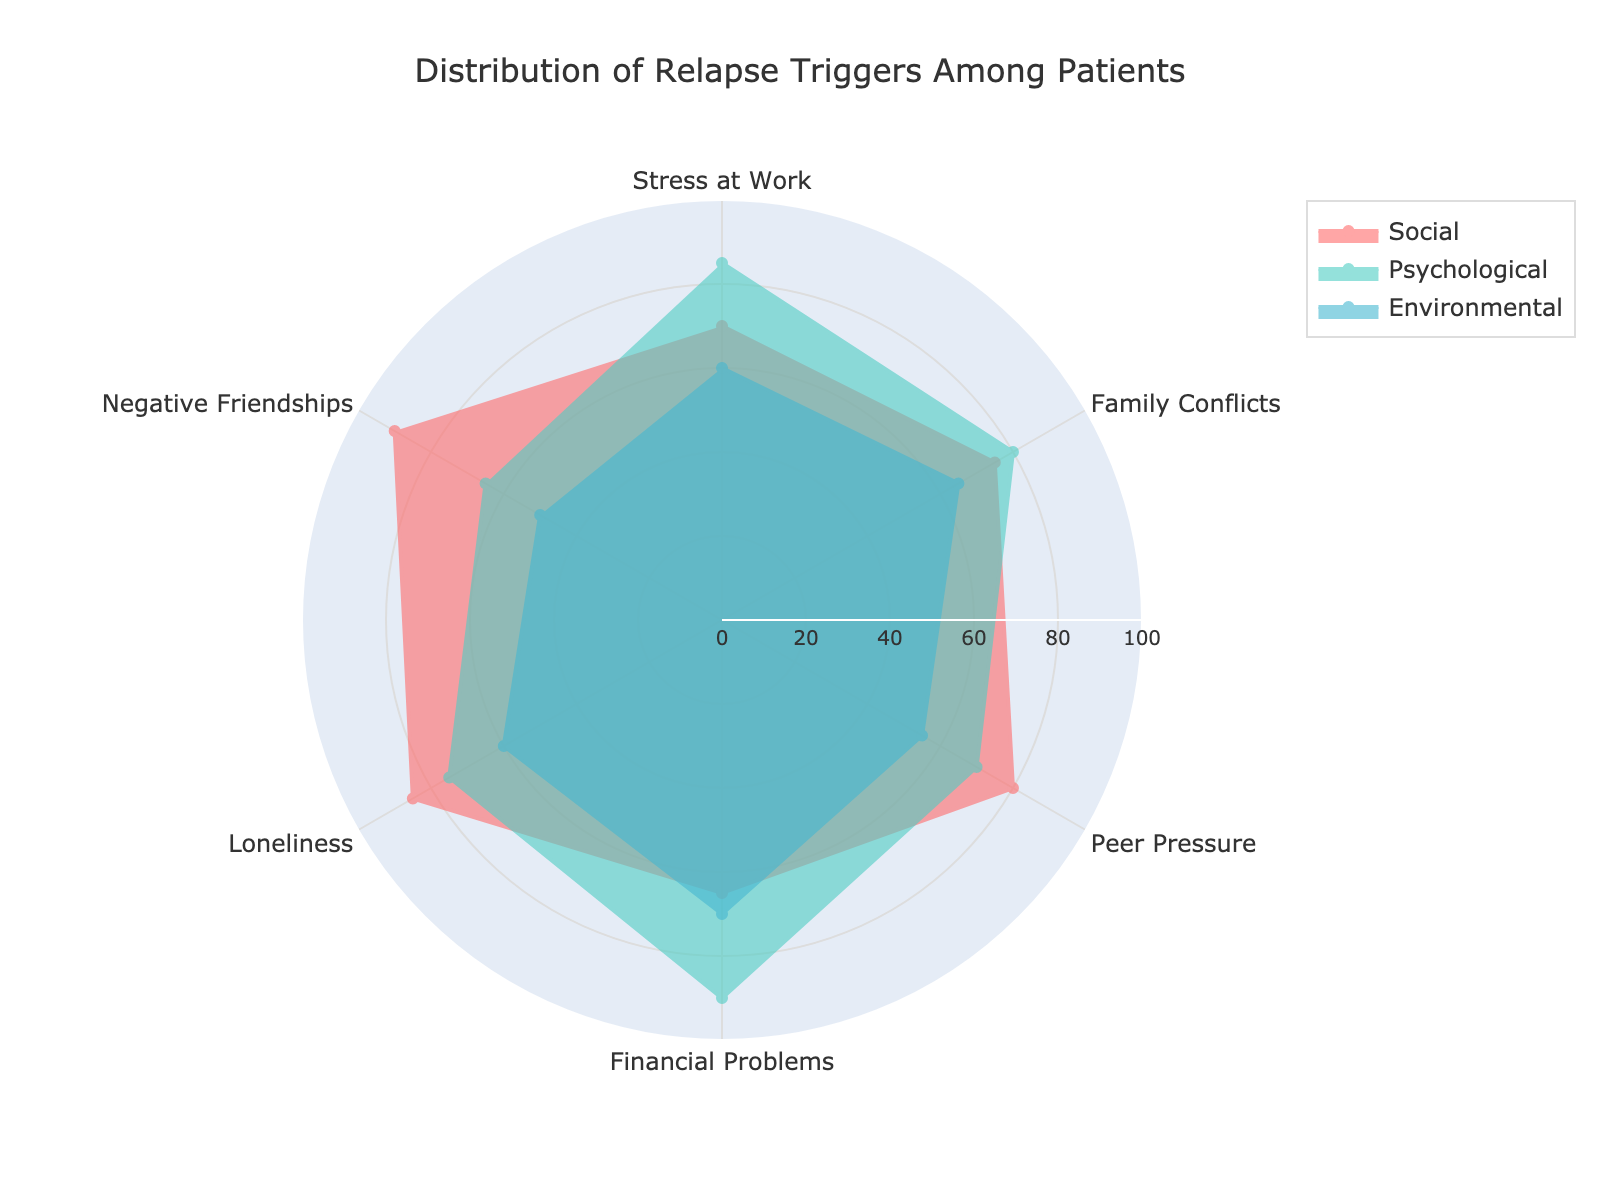What is the title of the figure? The title is displayed at the top of the radar chart, centered, and can be easily read.
Answer: Distribution of Relapse Triggers Among Patients How many categories are compared in the figure? By observing the different segments of the radar chart, we can count the number of labels around the chart's perimeter.
Answer: 6 Which relapse trigger category has the highest value for the Social group? By finding the peak value within the 'Social' line plot and checking the corresponding category, we identify the highest value.
Answer: Negative Friendships Which group shows the largest difference between Loneliness and Peer Pressure? By comparing the values for Loneliness and Peer Pressure for each group, we look for the group with the biggest numerical difference.
Answer: Psychological What is the smallest value among Environmental triggers? By reviewing the values plotted for the Environmental group, we identify the minimal value across all categories.
Answer: 50 Which category has the lowest value for the Psychological group? By glancing through the values for the Psychological group, we identify the category with the smallest number.
Answer: Negative Friendships What are the values for Family Conflicts in each group? By focusing on Family Conflicts, we can read off the values from each group’s respective line plot.
Answer: Social: 75, Psychological: 80, Environmental: 65 Which two categories show the closest values for the Environmental group? By comparing values within the Environmental group, we find the two categories with minimal differences.
Answer: Stress at Work and Loneliness What is the average value of Financial Problems across all groups? Sum the values of Financial Problems in Social, Psychological, and Environmental groups and divide by the number of groups (3). Explanation: (65 + 90 + 70) / 3 = 75.
Answer: 75 Which group shows the smallest overall variation among the categories? By examining the spread of values within each group, we determine which group has the least fluctuation from its minimal to maximal values.
Answer: Environmental 